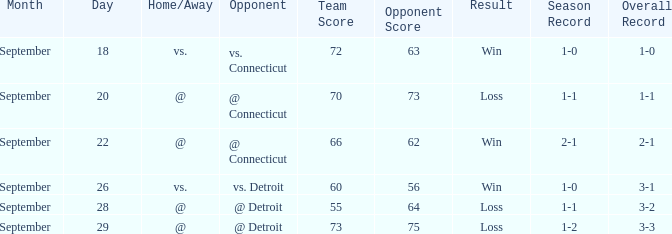WHAT IS THE SCORE WITH A RECORD OF 1-0? 72-63. 